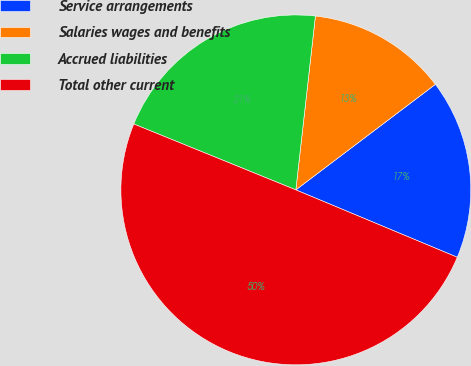<chart> <loc_0><loc_0><loc_500><loc_500><pie_chart><fcel>Service arrangements<fcel>Salaries wages and benefits<fcel>Accrued liabilities<fcel>Total other current<nl><fcel>16.6%<fcel>12.91%<fcel>20.64%<fcel>49.85%<nl></chart> 